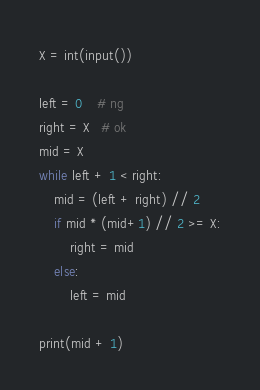<code> <loc_0><loc_0><loc_500><loc_500><_Python_>X = int(input())

left = 0    # ng
right = X   # ok
mid = X
while left + 1 < right:
    mid = (left + right) // 2
    if mid * (mid+1) // 2 >= X:
        right = mid
    else:
        left = mid

print(mid + 1)
</code> 